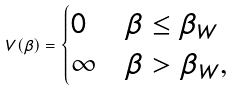Convert formula to latex. <formula><loc_0><loc_0><loc_500><loc_500>V ( \beta ) = \begin{cases} 0 & \beta \leq \beta _ { W } \\ \infty & \beta > \beta _ { W } , \end{cases}</formula> 